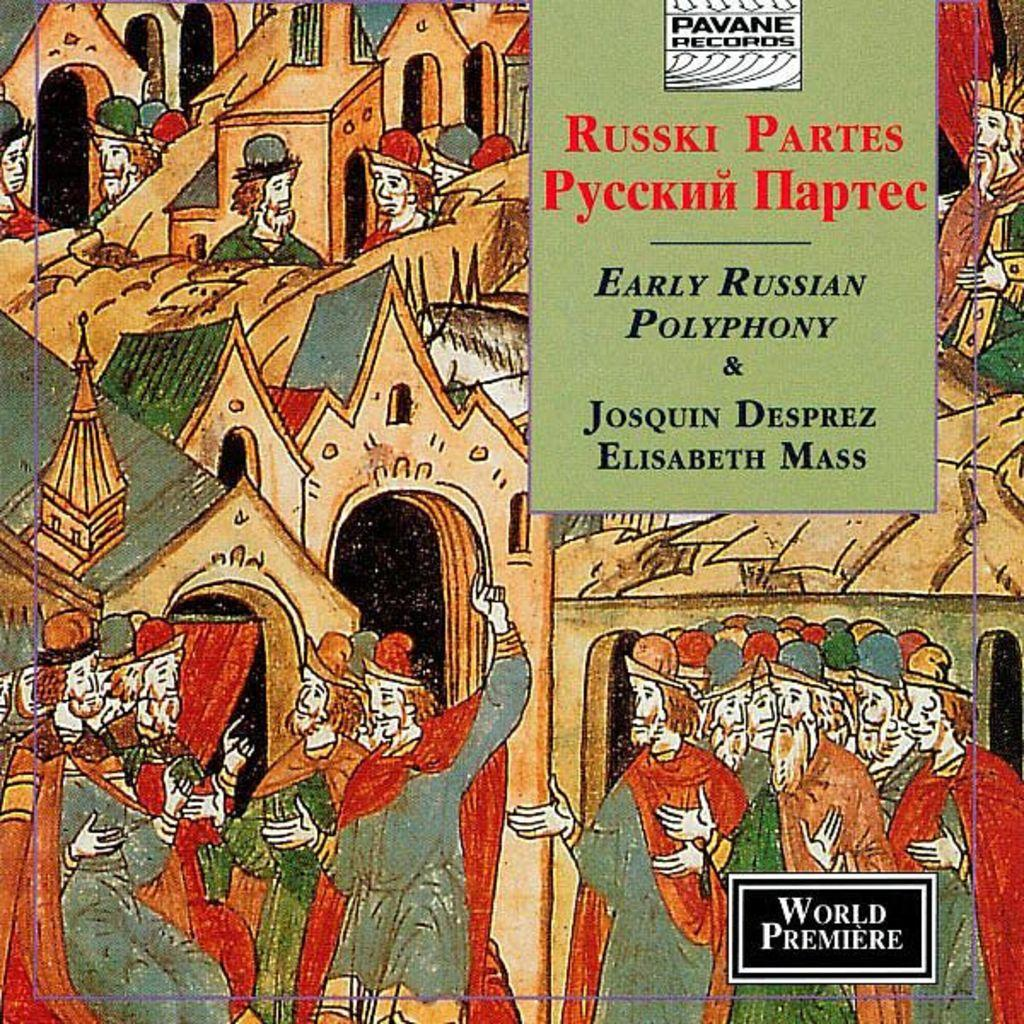<image>
Create a compact narrative representing the image presented. Cover showing people having a conversation titled "Russki Partes". 